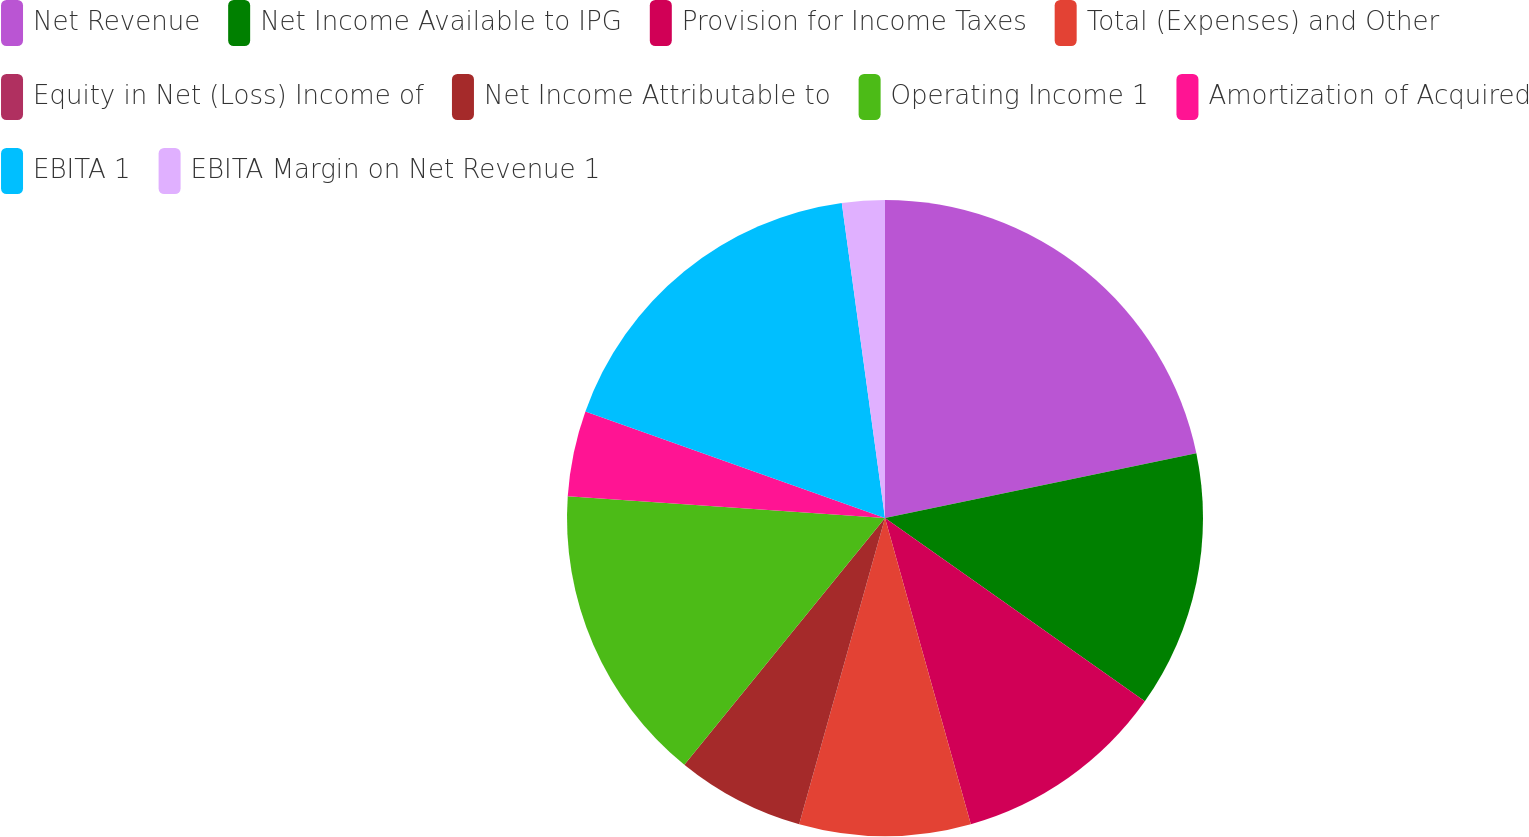<chart> <loc_0><loc_0><loc_500><loc_500><pie_chart><fcel>Net Revenue<fcel>Net Income Available to IPG<fcel>Provision for Income Taxes<fcel>Total (Expenses) and Other<fcel>Equity in Net (Loss) Income of<fcel>Net Income Attributable to<fcel>Operating Income 1<fcel>Amortization of Acquired<fcel>EBITA 1<fcel>EBITA Margin on Net Revenue 1<nl><fcel>21.74%<fcel>13.04%<fcel>10.87%<fcel>8.7%<fcel>0.0%<fcel>6.52%<fcel>15.22%<fcel>4.35%<fcel>17.39%<fcel>2.17%<nl></chart> 